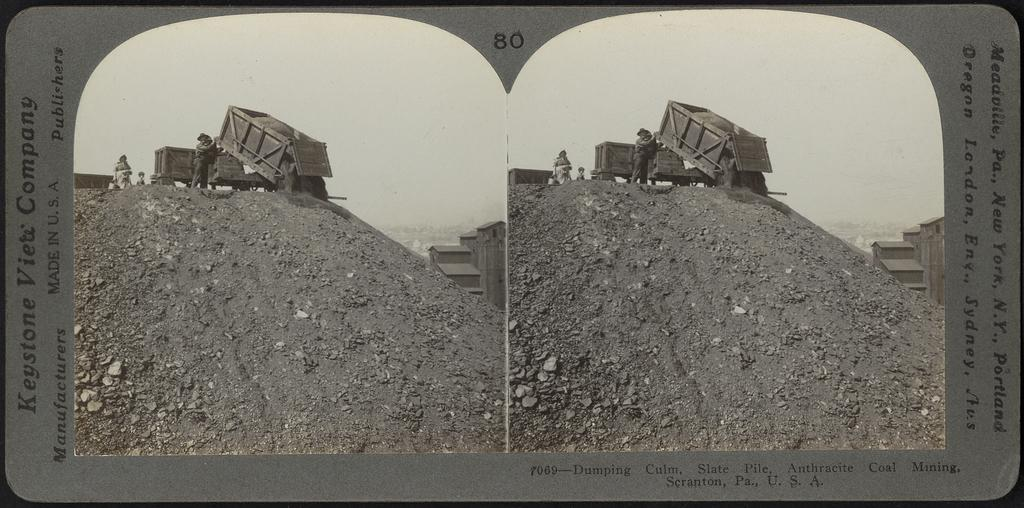<image>
Provide a brief description of the given image. The picture here is made in the United States if America 